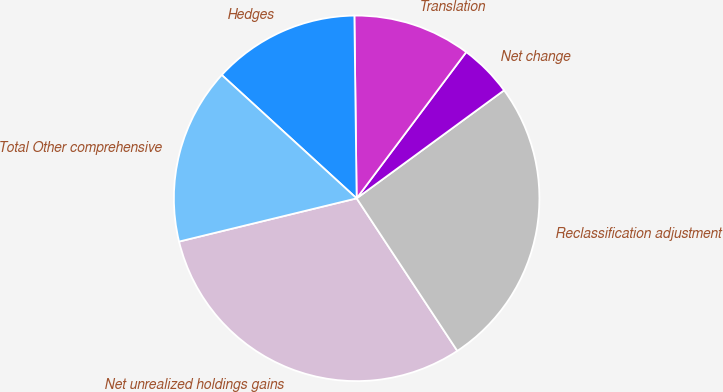<chart> <loc_0><loc_0><loc_500><loc_500><pie_chart><fcel>Net unrealized holdings gains<fcel>Reclassification adjustment<fcel>Net change<fcel>Translation<fcel>Hedges<fcel>Total Other comprehensive<nl><fcel>30.48%<fcel>25.78%<fcel>4.7%<fcel>10.43%<fcel>13.01%<fcel>15.59%<nl></chart> 